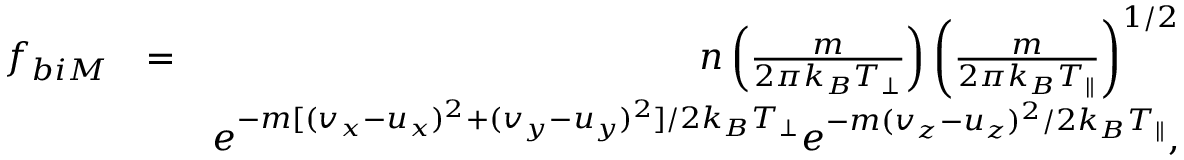Convert formula to latex. <formula><loc_0><loc_0><loc_500><loc_500>\begin{array} { r l r } { f _ { b i M } } & { = } & { n \left ( \frac { m } { 2 \pi k _ { B } T _ { \perp } } \right ) \left ( \frac { m } { 2 \pi k _ { B } T _ { \| } } \right ) ^ { 1 / 2 } } \\ & { e ^ { - m [ ( v _ { x } - u _ { x } ) ^ { 2 } + ( v _ { y } - u _ { y } ) ^ { 2 } ] / 2 k _ { B } T _ { \perp } } e ^ { - m ( v _ { z } - u _ { z } ) ^ { 2 } / 2 k _ { B } T _ { \| } } , } \end{array}</formula> 